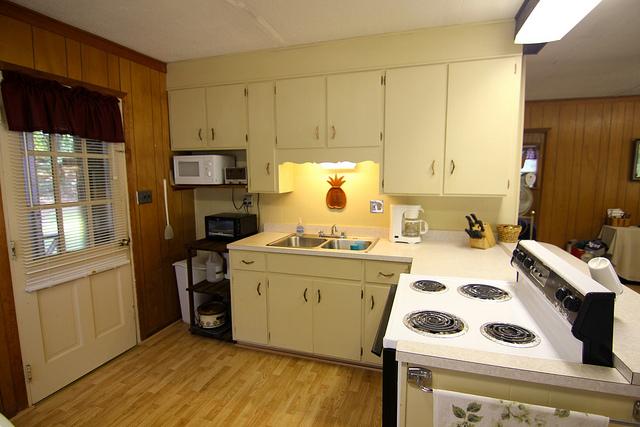Are there dishes in the sink?
Be succinct. No. What is the dog doing near the door?
Keep it brief. Nothing. Is the stove a gas stove?
Answer briefly. No. Is anyone living in the house?
Answer briefly. Yes. Is there corn on the wall?
Be succinct. No. Is this room organized?
Short answer required. Yes. Who does the photography?
Answer briefly. Man. Is it daytime outside?
Keep it brief. Yes. What are the cabinets made from?
Write a very short answer. Wood. What is hanging in the window?
Write a very short answer. Blinds. Is this a modern kitchen?
Keep it brief. No. Is anything missing from the doors and drawers?
Be succinct. No. What color is the countertop?
Keep it brief. White. Is there a picture above the sink?
Be succinct. Yes. What room is next to the living room?
Keep it brief. Kitchen. Is there a microwave oven?
Short answer required. Yes. Are there blinds on the windows?
Short answer required. Yes. 